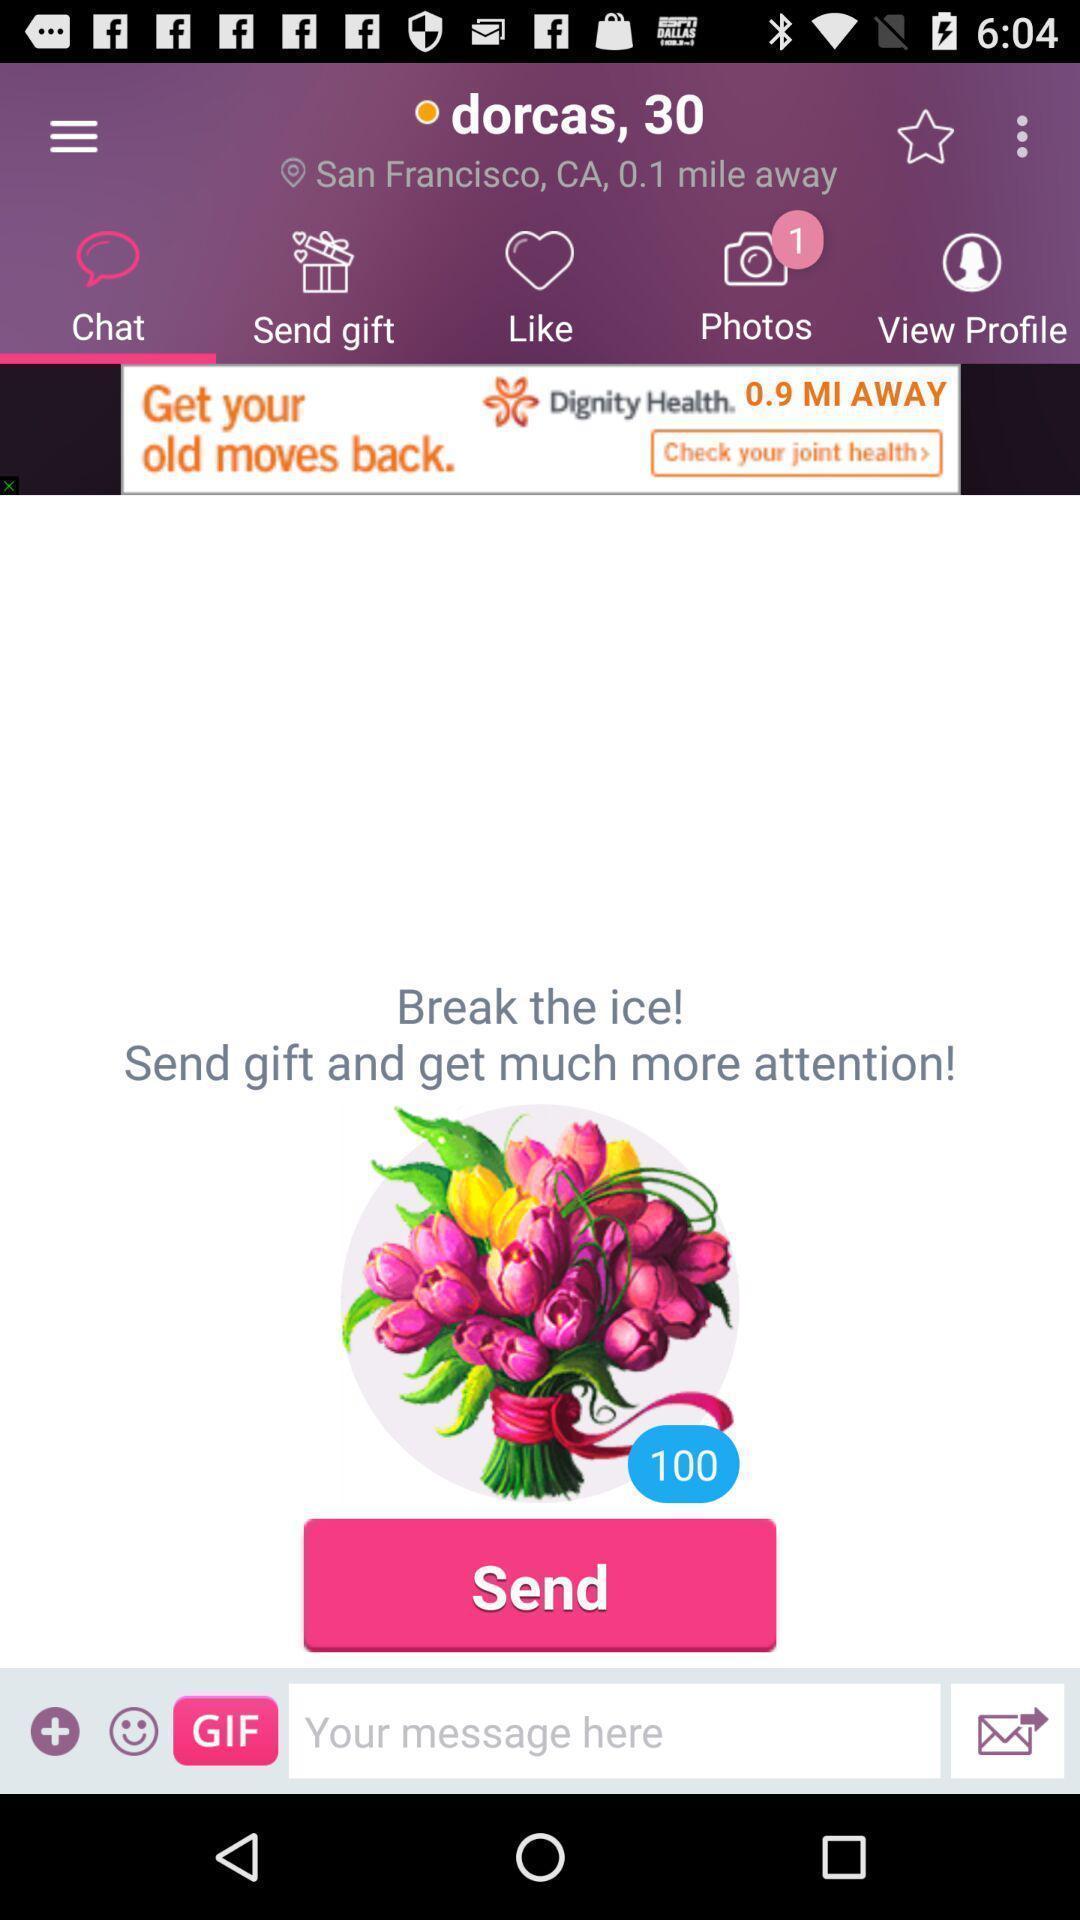Describe this image in words. Page for sending a message. 